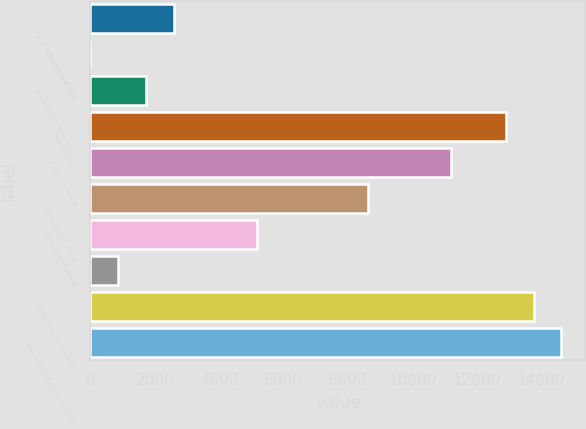Convert chart to OTSL. <chart><loc_0><loc_0><loc_500><loc_500><bar_chart><fcel>Cash and cash equivalents<fcel>Restricted cash<fcel>Investment securities<fcel>Credit card (2)<fcel>Personal loans<fcel>Private student loans<fcel>PCI student loans<fcel>Other<fcel>Total loan receivables<fcel>Total interest-earning assets<nl><fcel>2586.2<fcel>2<fcel>1724.8<fcel>12923<fcel>11200.2<fcel>8616<fcel>5170.4<fcel>863.4<fcel>13784.4<fcel>14645.8<nl></chart> 